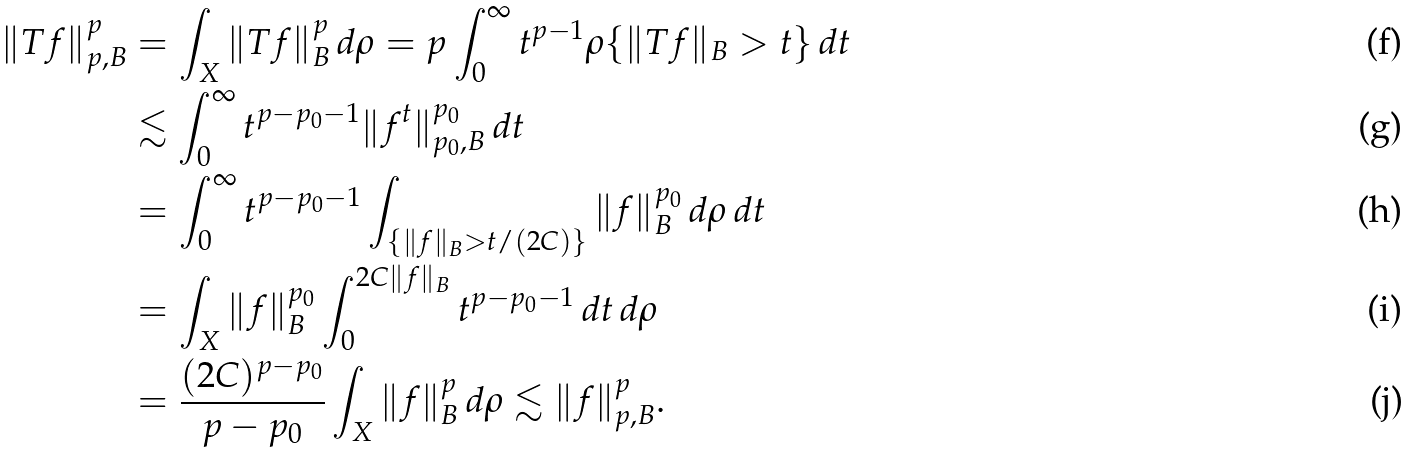<formula> <loc_0><loc_0><loc_500><loc_500>\| T f \| _ { p , B } ^ { p } & = \int _ { X } \| T f \| _ { B } ^ { p } \, d \rho = p \int _ { 0 } ^ { \infty } t ^ { p - 1 } \rho \{ \| T f \| _ { B } > t \} \, d t \\ & \lesssim \int _ { 0 } ^ { \infty } t ^ { p - p _ { 0 } - 1 } \| f ^ { t } \| _ { p _ { 0 } , B } ^ { p _ { 0 } } \, d t \\ & = \int _ { 0 } ^ { \infty } t ^ { p - p _ { 0 } - 1 } \int _ { \{ \| f \| _ { B } > t / ( 2 C ) \} } \| f \| _ { B } ^ { p _ { 0 } } \, d \rho \, d t \\ & = \int _ { X } \| f \| _ { B } ^ { p _ { 0 } } \int _ { 0 } ^ { 2 C \| f \| _ { B } } t ^ { p - p _ { 0 } - 1 } \, d t \, d \rho \\ & = \frac { ( 2 C ) ^ { p - p _ { 0 } } } { p - p _ { 0 } } \int _ { X } \| f \| _ { B } ^ { p } \, d \rho \lesssim \| f \| _ { p , B } ^ { p } .</formula> 